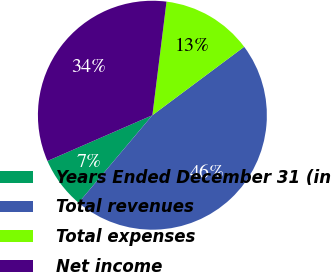Convert chart. <chart><loc_0><loc_0><loc_500><loc_500><pie_chart><fcel>Years Ended December 31 (in<fcel>Total revenues<fcel>Total expenses<fcel>Net income<nl><fcel>7.31%<fcel>46.34%<fcel>12.83%<fcel>33.51%<nl></chart> 